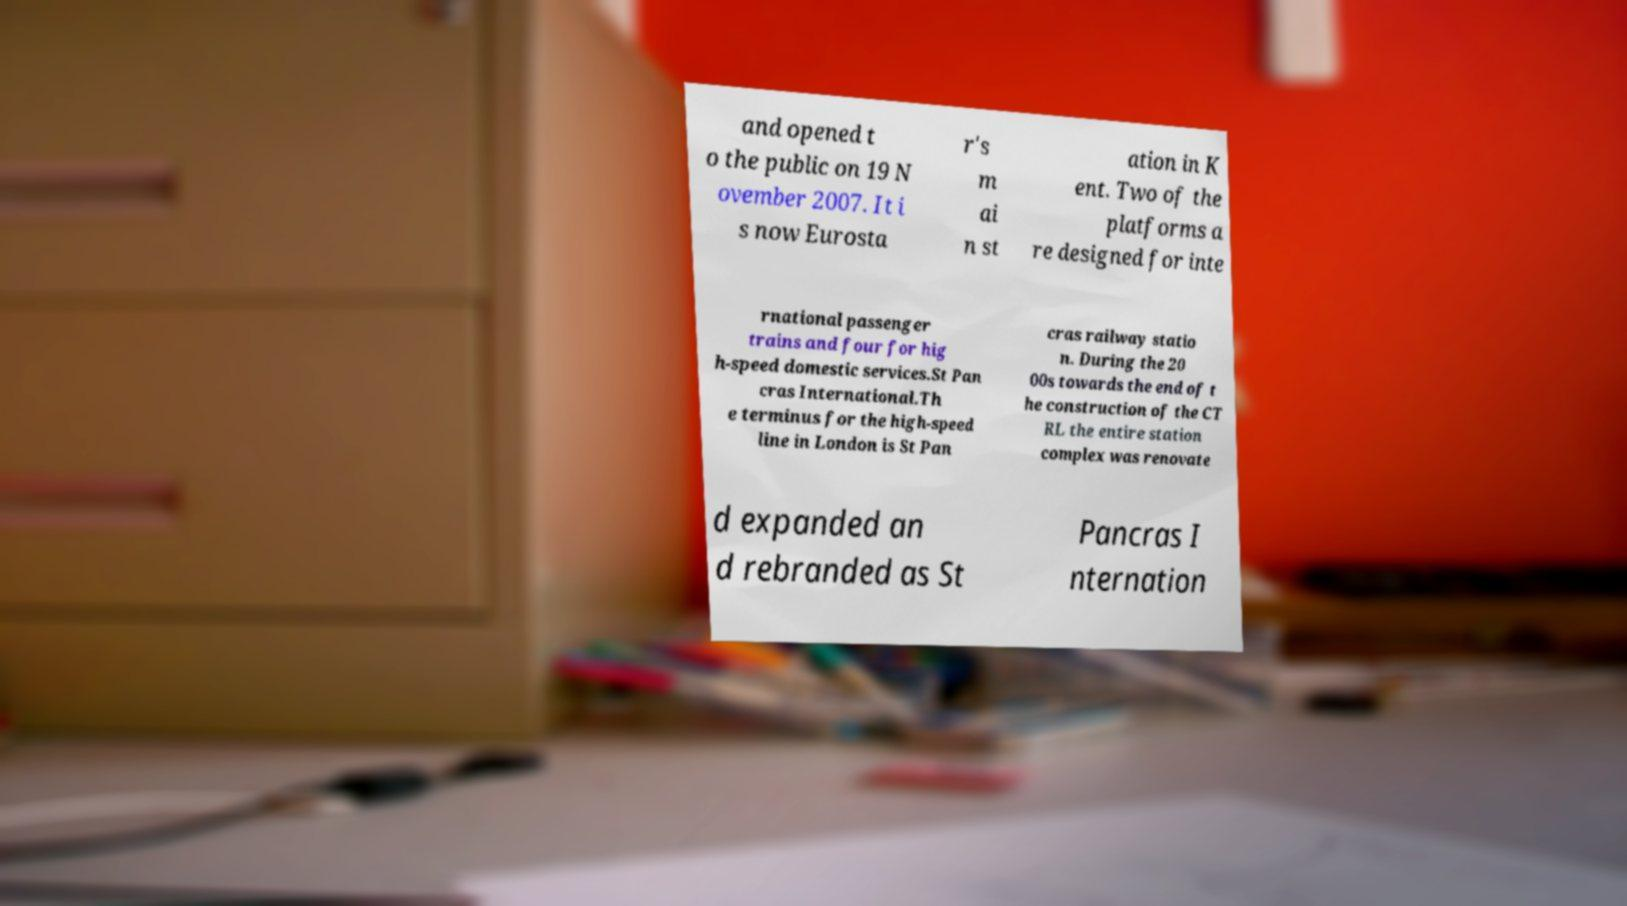For documentation purposes, I need the text within this image transcribed. Could you provide that? and opened t o the public on 19 N ovember 2007. It i s now Eurosta r's m ai n st ation in K ent. Two of the platforms a re designed for inte rnational passenger trains and four for hig h-speed domestic services.St Pan cras International.Th e terminus for the high-speed line in London is St Pan cras railway statio n. During the 20 00s towards the end of t he construction of the CT RL the entire station complex was renovate d expanded an d rebranded as St Pancras I nternation 